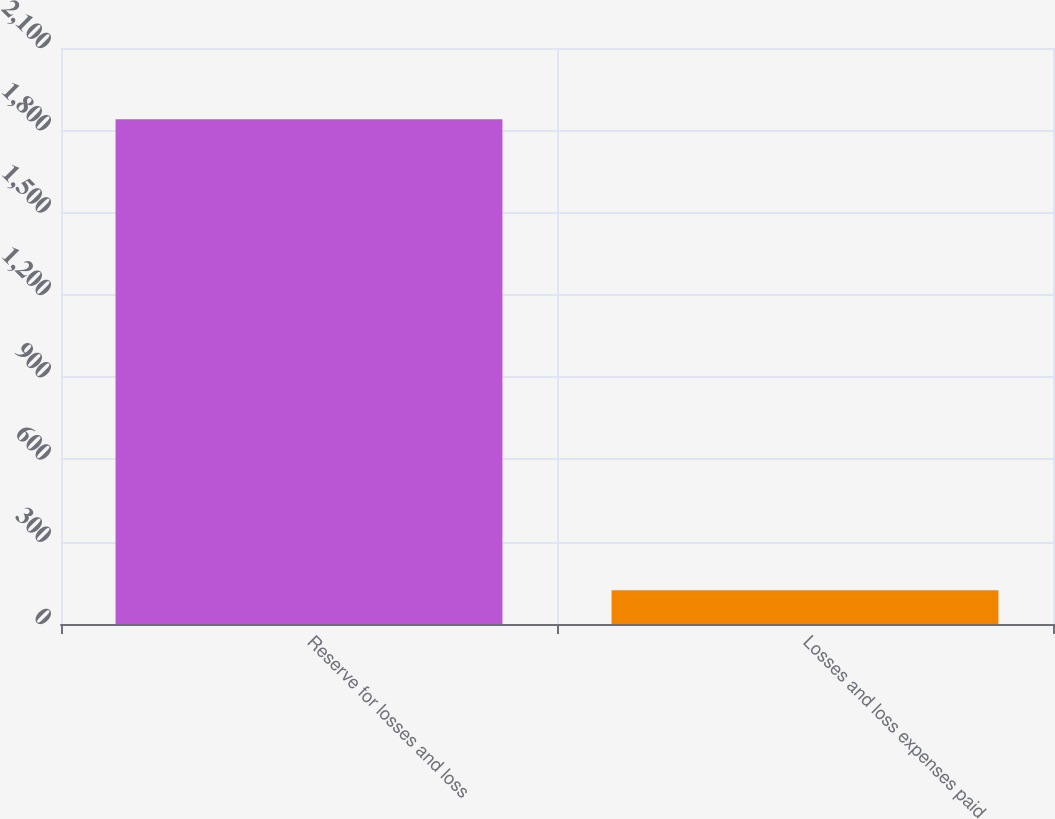Convert chart. <chart><loc_0><loc_0><loc_500><loc_500><bar_chart><fcel>Reserve for losses and loss<fcel>Losses and loss expenses paid<nl><fcel>1840<fcel>123<nl></chart> 